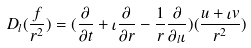Convert formula to latex. <formula><loc_0><loc_0><loc_500><loc_500>D _ { l } ( \frac { f } { r ^ { 2 } } ) = ( \frac { \partial } { \partial t } + \iota \frac { \partial } { \partial r } - \frac { 1 } { r } \frac { \partial } { \partial _ { l } \iota } ) ( \frac { u + \iota v } { r ^ { 2 } } )</formula> 